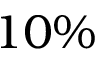Convert formula to latex. <formula><loc_0><loc_0><loc_500><loc_500>1 0 \%</formula> 